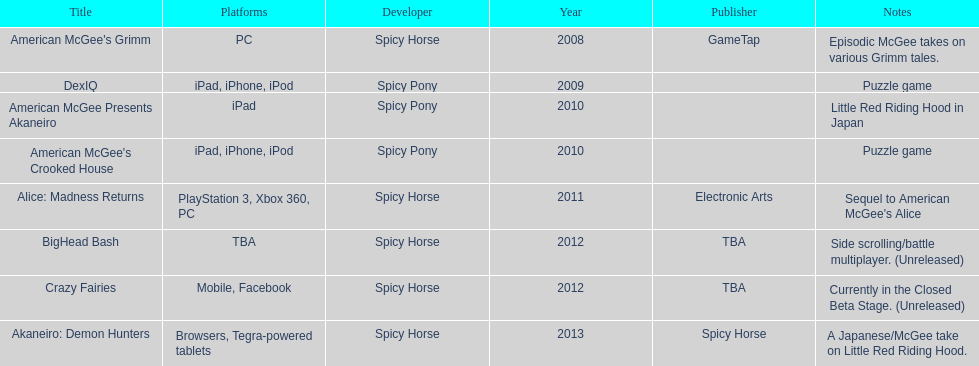What was the last game created by spicy horse Akaneiro: Demon Hunters. 